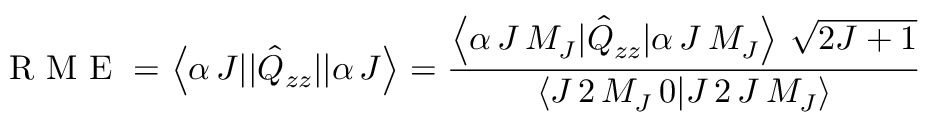<formula> <loc_0><loc_0><loc_500><loc_500>{ R M E } = \left < \alpha \, J | | \hat { Q } _ { z z } | | \alpha \, J \right > = \frac { \left < \alpha \, J \, M _ { J } | \hat { Q } _ { z z } | \alpha \, J \, M _ { J } \right > \, \sqrt { 2 J + 1 } } { \left < J \, 2 \, M _ { J } \, 0 | J \, 2 \, J \, M _ { J } \right > }</formula> 